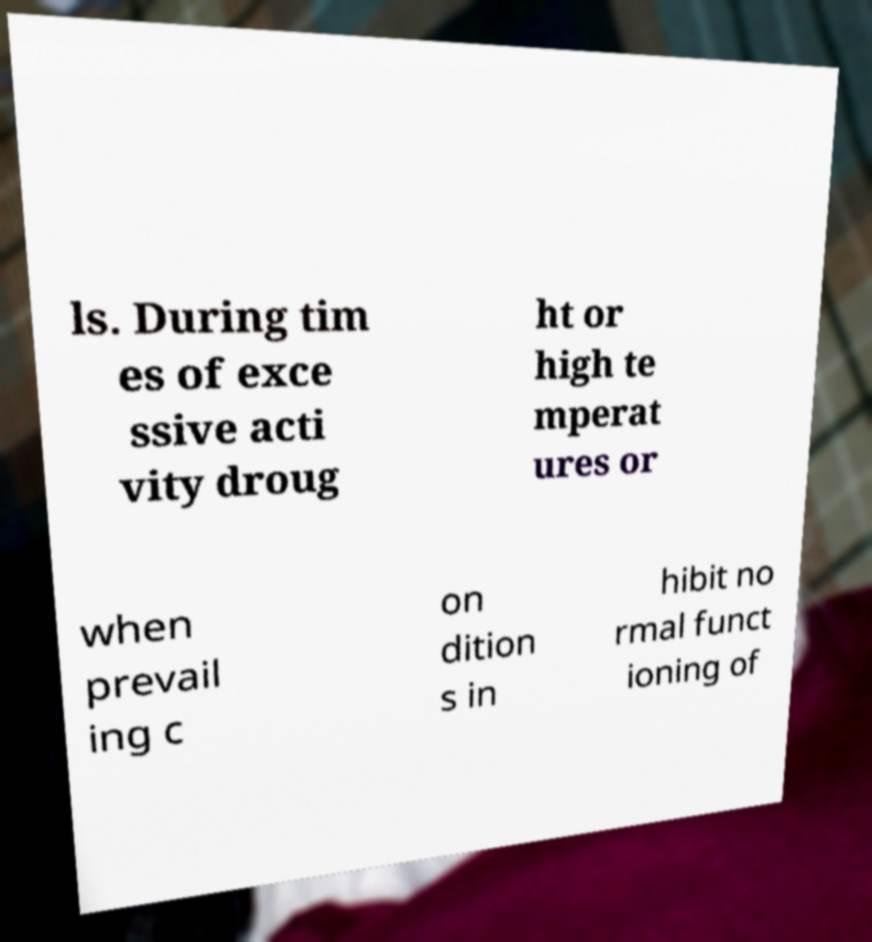What messages or text are displayed in this image? I need them in a readable, typed format. ls. During tim es of exce ssive acti vity droug ht or high te mperat ures or when prevail ing c on dition s in hibit no rmal funct ioning of 